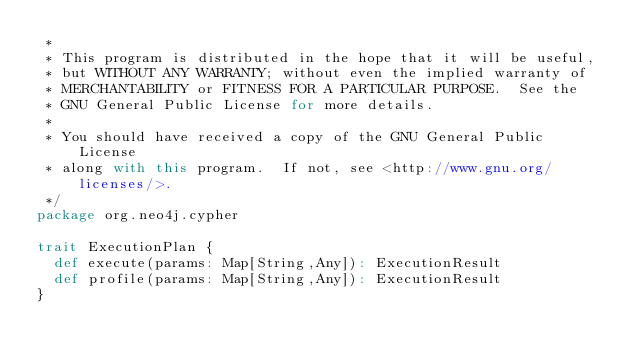Convert code to text. <code><loc_0><loc_0><loc_500><loc_500><_Scala_> *
 * This program is distributed in the hope that it will be useful,
 * but WITHOUT ANY WARRANTY; without even the implied warranty of
 * MERCHANTABILITY or FITNESS FOR A PARTICULAR PURPOSE.  See the
 * GNU General Public License for more details.
 *
 * You should have received a copy of the GNU General Public License
 * along with this program.  If not, see <http://www.gnu.org/licenses/>.
 */
package org.neo4j.cypher

trait ExecutionPlan {
  def execute(params: Map[String,Any]): ExecutionResult
  def profile(params: Map[String,Any]): ExecutionResult
}</code> 